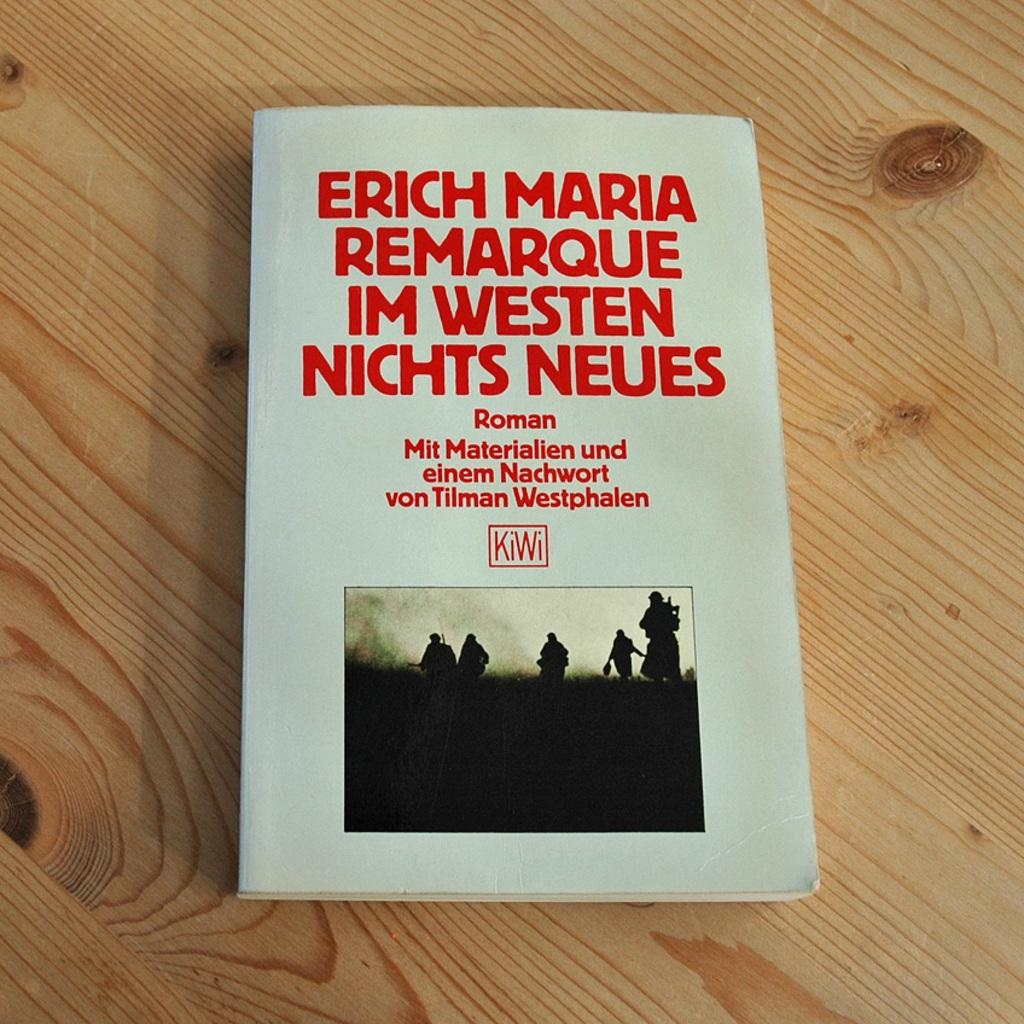<image>
Summarize the visual content of the image. The novel is titled Remarque Im Westen Nichts Neues. 